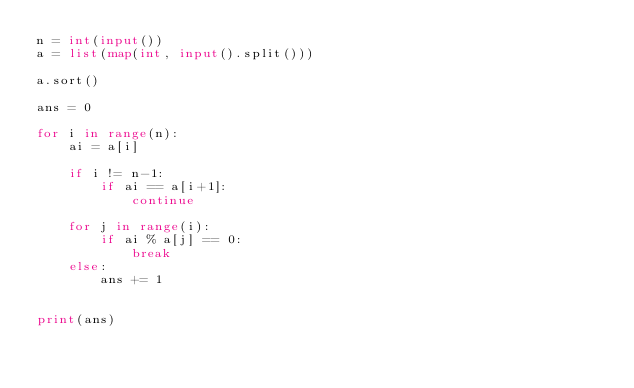Convert code to text. <code><loc_0><loc_0><loc_500><loc_500><_Python_>n = int(input())
a = list(map(int, input().split()))

a.sort()

ans = 0

for i in range(n):
    ai = a[i]

    if i != n-1:
        if ai == a[i+1]:
            continue

    for j in range(i):
        if ai % a[j] == 0:
            break
    else:
        ans += 1


print(ans)</code> 